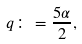<formula> <loc_0><loc_0><loc_500><loc_500>q \colon = \frac { 5 \alpha } { 2 } ,</formula> 